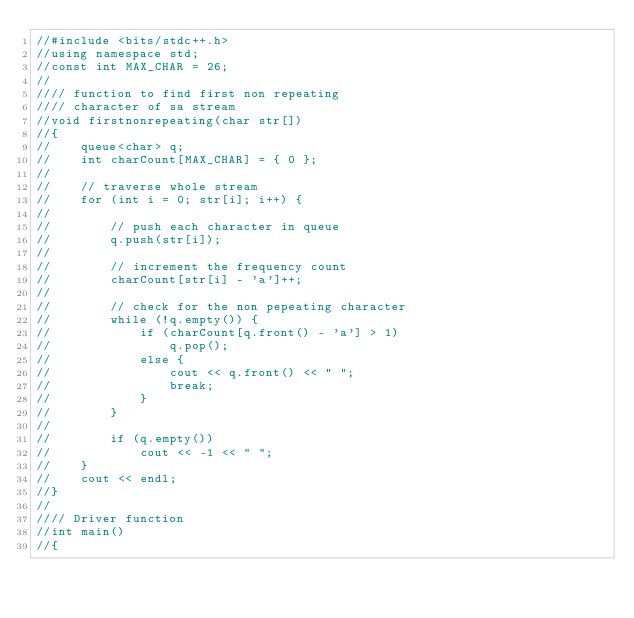<code> <loc_0><loc_0><loc_500><loc_500><_C++_>//#include <bits/stdc++.h>
//using namespace std;
//const int MAX_CHAR = 26;
//
//// function to find first non repeating
//// character of sa stream
//void firstnonrepeating(char str[])
//{
//    queue<char> q;
//    int charCount[MAX_CHAR] = { 0 };
//
//    // traverse whole stream
//    for (int i = 0; str[i]; i++) {
//
//        // push each character in queue
//        q.push(str[i]);
//
//        // increment the frequency count
//        charCount[str[i] - 'a']++;
//
//        // check for the non pepeating character
//        while (!q.empty()) {
//            if (charCount[q.front() - 'a'] > 1)
//                q.pop();
//            else {
//                cout << q.front() << " ";
//                break;
//            }
//        }
//
//        if (q.empty())
//            cout << -1 << " ";
//    }
//    cout << endl;
//}
//
//// Driver function
//int main()
//{</code> 